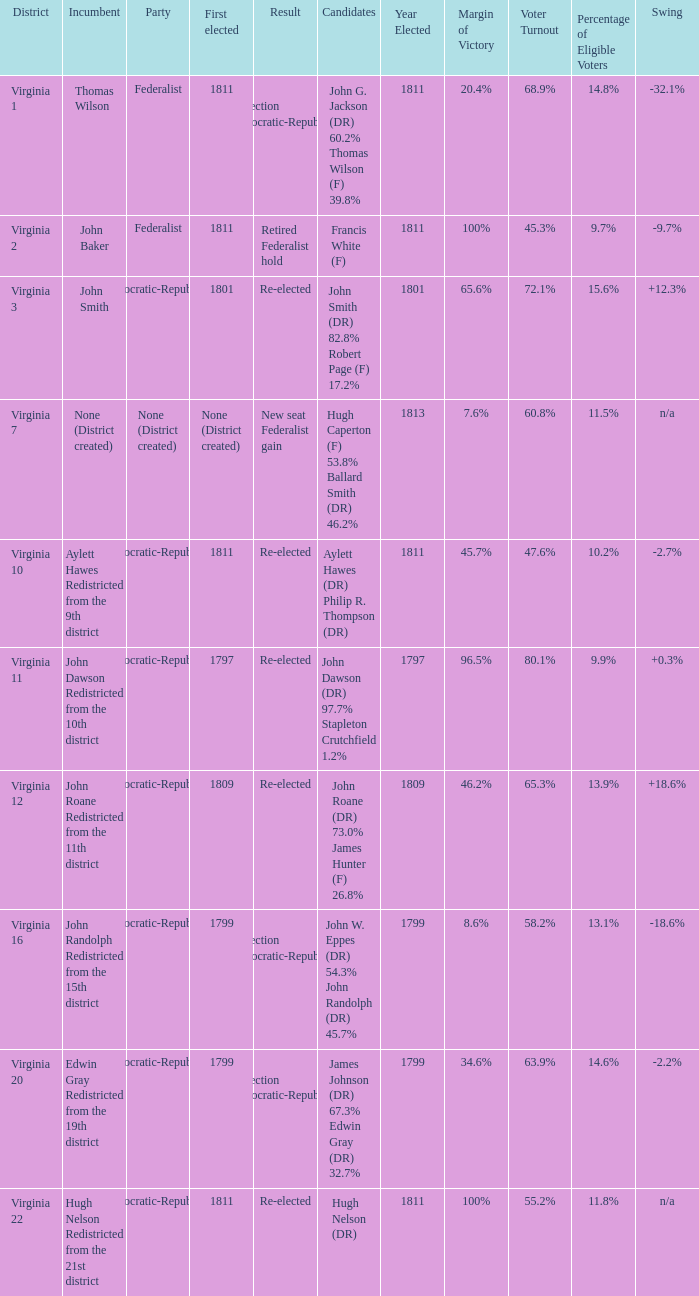Name the distrct for thomas wilson Virginia 1. 